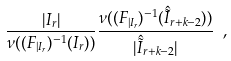Convert formula to latex. <formula><loc_0><loc_0><loc_500><loc_500>\frac { | I _ { r } | } { \nu ( ( F _ { | I _ { r } } ) ^ { - 1 } ( I _ { r } ) ) } \frac { \nu ( ( F _ { | I _ { r } } ) ^ { - 1 } ( \hat { \tilde { I } } _ { r + k - 2 } ) ) } { | \hat { \tilde { I } } _ { r + k - 2 } | } \ ,</formula> 